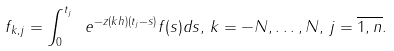<formula> <loc_0><loc_0><loc_500><loc_500>f _ { k , j } = \int _ { 0 } ^ { t _ { j } } \ e ^ { - z ( k h ) ( t _ { j } - s ) } f ( s ) d s , \, k = - N , \dots , N , \, j = \overline { 1 , n } .</formula> 